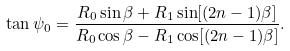Convert formula to latex. <formula><loc_0><loc_0><loc_500><loc_500>\tan \psi _ { 0 } = \frac { R _ { 0 } \sin \beta + R _ { 1 } \sin [ ( 2 n - 1 ) \beta ] } { R _ { 0 } \cos \beta - R _ { 1 } \cos [ ( 2 n - 1 ) \beta ] } .</formula> 